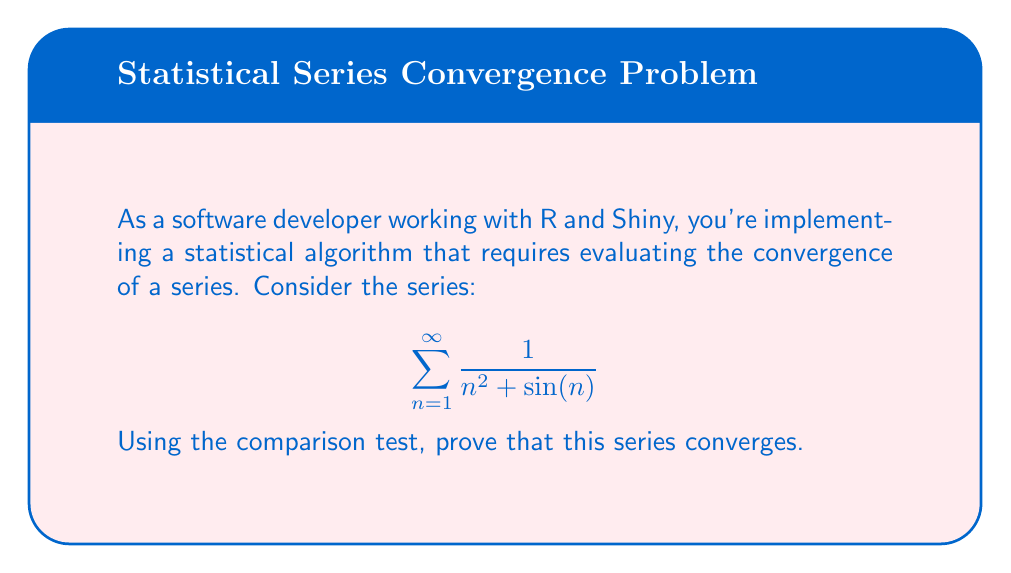Can you solve this math problem? Let's approach this step-by-step:

1) First, we need to find a series to compare with our given series. We know that:

   $$0 \leq \sin(n) \leq 1$$ for all real n.

2) Therefore, $$n^2 \leq n^2 + \sin(n) \leq n^2 + 1$$ for all n ≥ 1.

3) Taking reciprocals (and flipping the inequality since we're dealing with positive terms):

   $$\frac{1}{n^2 + 1} \leq \frac{1}{n^2 + \sin(n)} \leq \frac{1}{n^2}$$ for all n ≥ 1.

4) We know that the p-series $$\sum_{n=1}^{\infty} \frac{1}{n^2}$$ converges (it's the famous Basel problem with sum π²/6).

5) By the comparison test, if $$\sum_{n=1}^{\infty} \frac{1}{n^2}$$ converges, and $$\frac{1}{n^2 + \sin(n)} \leq \frac{1}{n^2}$$ for all n ≥ 1, then $$\sum_{n=1}^{\infty} \frac{1}{n^2 + \sin(n)}$$ must also converge.

6) Therefore, we have proven that the given series converges using the comparison test.
Answer: The series converges by comparison with $$\sum_{n=1}^{\infty} \frac{1}{n^2}$$. 